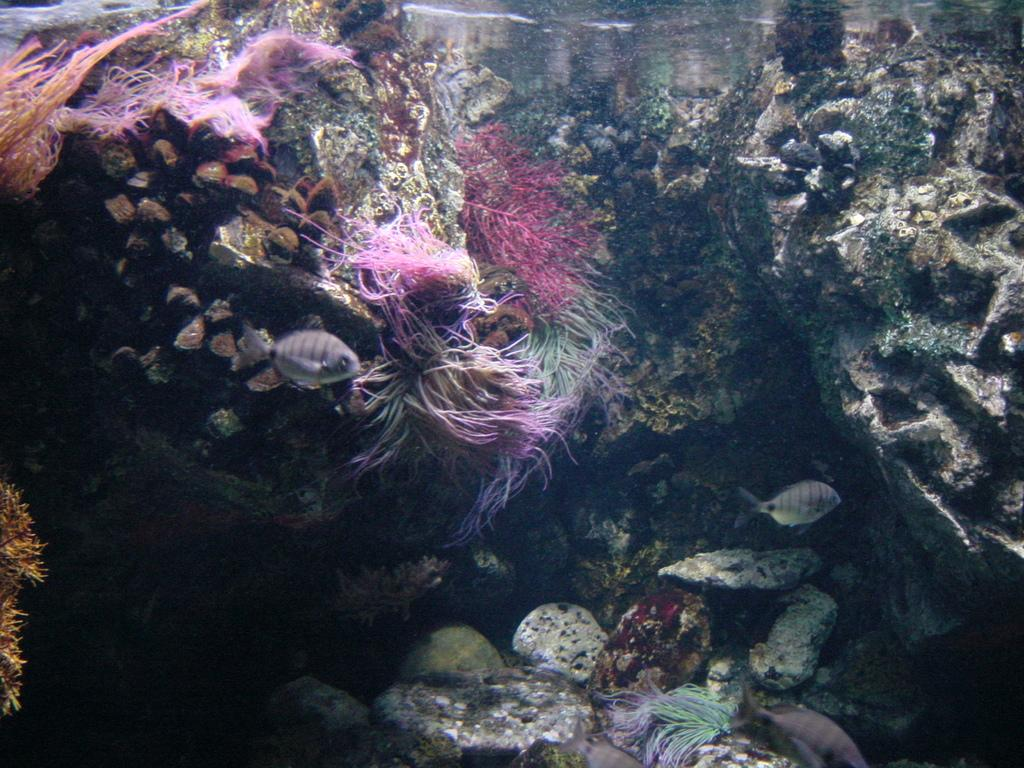What type of natural elements can be seen in the image? There are rocks and water in the image. Are there any living organisms visible in the image? Yes, there are fishes in the image. What type of ring can be seen on the finger of the fish in the image? There are no rings or fingers present in the image, as it features rocks, water, and fishes. 